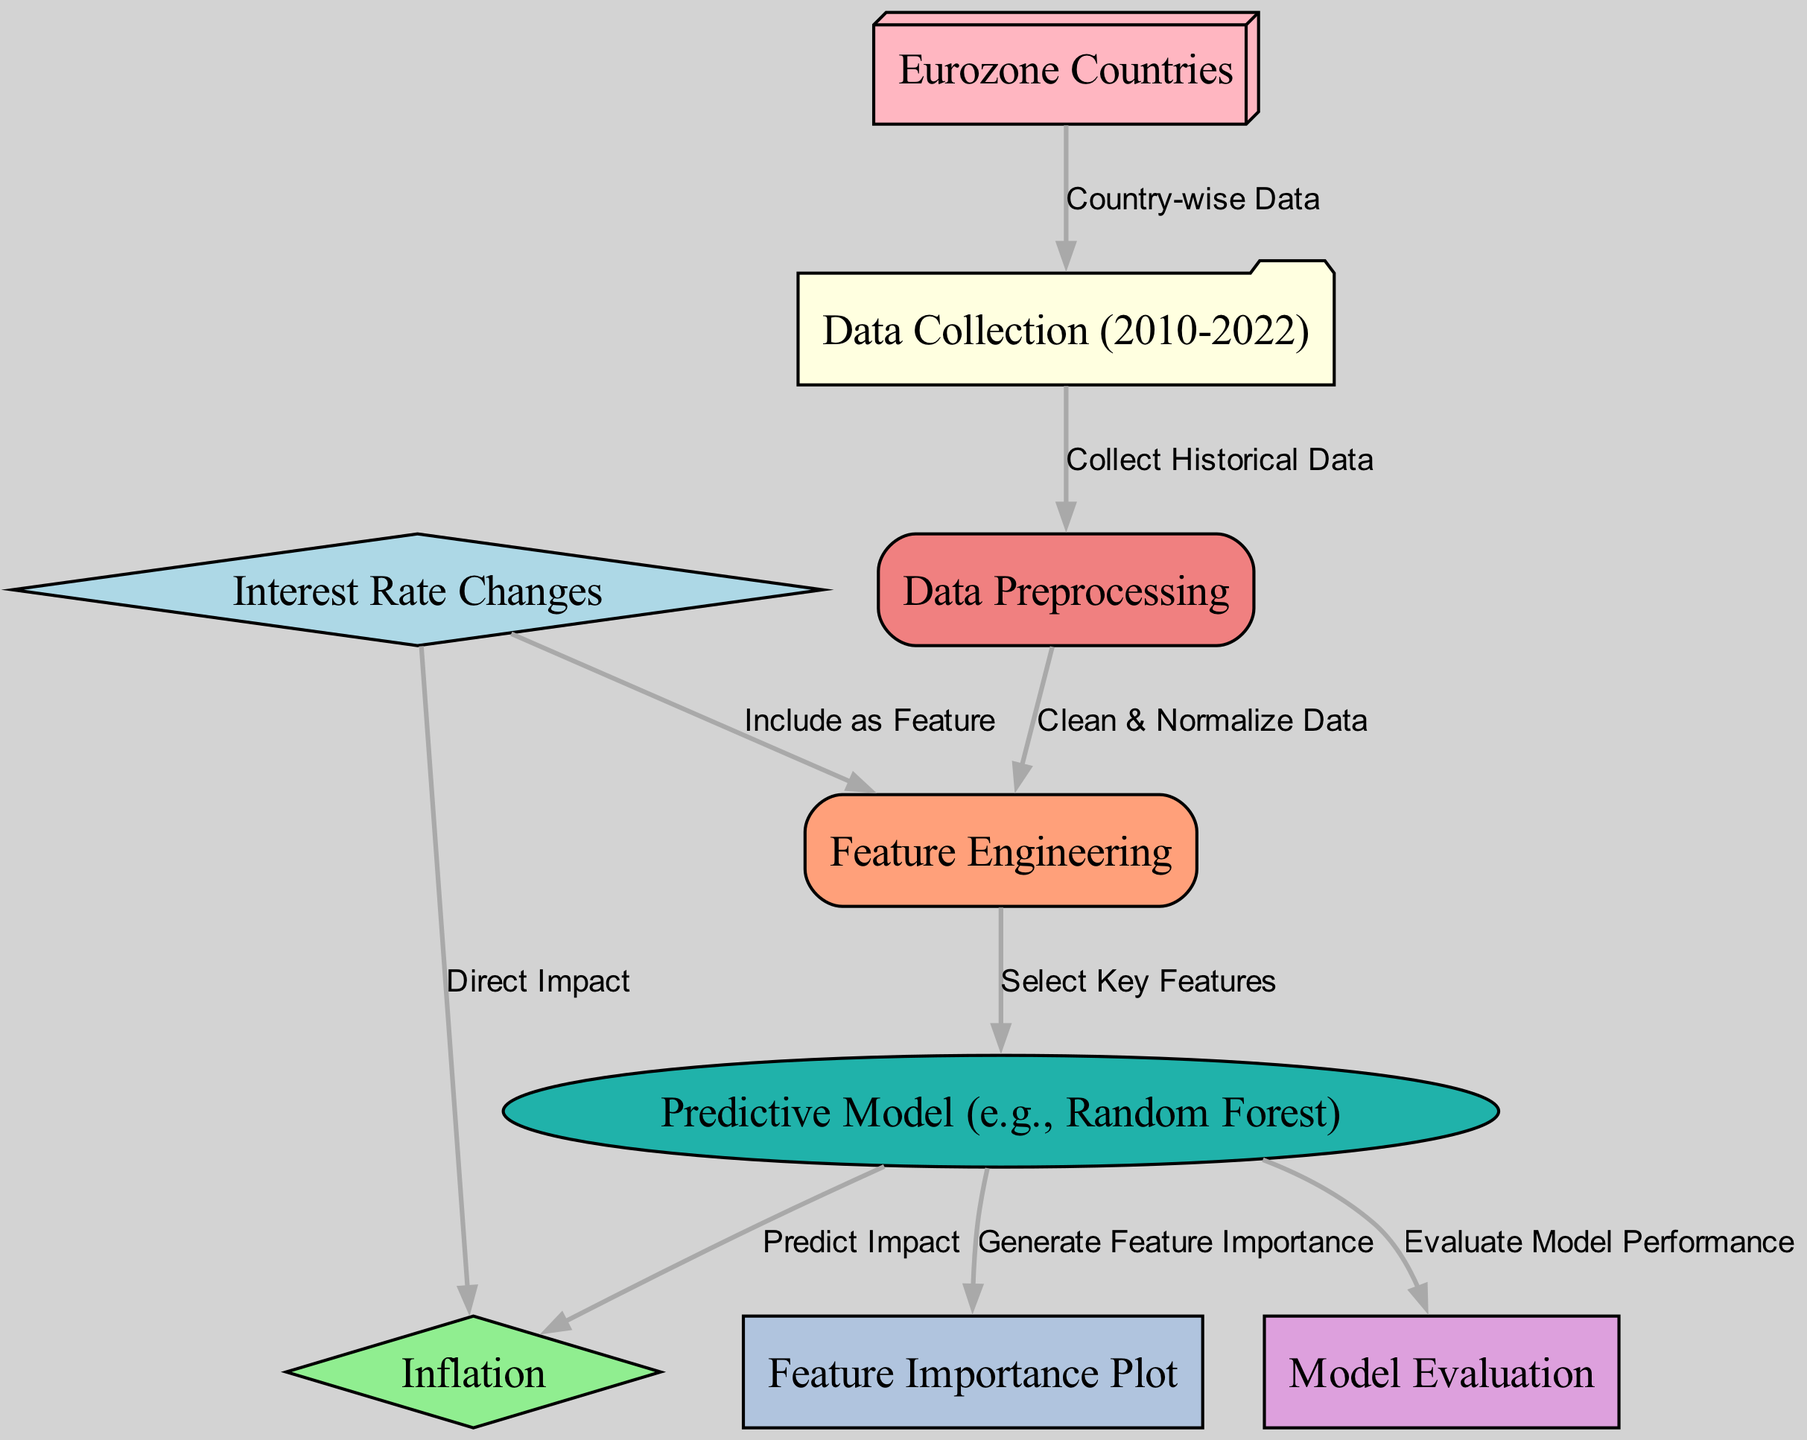What is the first step in the diagram? The diagram indicates that the first step is "Data Collection (2010-2022)" as it is the initial node from which all other processes stem.
Answer: Data Collection (2010-2022) How many nodes are present in the diagram? By counting all the individual entities represented, there are 9 distinct nodes in total.
Answer: 9 What is the relationship between Interest Rate Changes and Inflation? The diagram shows a direct relationship indicating that "Interest Rate Changes" have a "Direct Impact" on "Inflation".
Answer: Direct Impact Which node follows Data Preprocessing? The next step after "Data Preprocessing" in the flow is "Feature Engineering," showing the sequence of data handling processes.
Answer: Feature Engineering What modeling technique is used in the predictive model? The node labeled "Predictive Model" specifies an example of a modeling technique, which is "Random Forest."
Answer: Random Forest What is the output from the Predictive Model node? The diagram indicates that the output from the "Predictive Model" node will be "Inflation," as it predicts the impact on this economic metric.
Answer: Inflation Which process includes Interest Rate Changes as a feature? The flow indicates that "Feature Engineering" includes "Interest Rate Changes" as an important aspect for modeling.
Answer: Feature Engineering What does the Feature Importance Plot provide? The connection from "Predictive Model" to "Feature Importance Plot" implies that this plot generates insights regarding which features are most influential in predicting inflation.
Answer: Generate Feature Importance How is data collected in the context of Eurozone countries? The link from "Eurozone Countries" to "Data Collection (2010-2022)" specifies that data is collected on a country-wise basis for the analysis.
Answer: Country-wise Data 